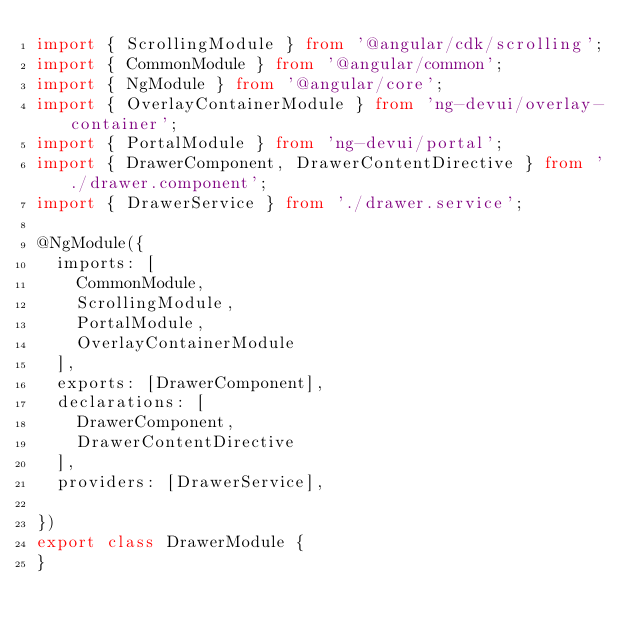<code> <loc_0><loc_0><loc_500><loc_500><_TypeScript_>import { ScrollingModule } from '@angular/cdk/scrolling';
import { CommonModule } from '@angular/common';
import { NgModule } from '@angular/core';
import { OverlayContainerModule } from 'ng-devui/overlay-container';
import { PortalModule } from 'ng-devui/portal';
import { DrawerComponent, DrawerContentDirective } from './drawer.component';
import { DrawerService } from './drawer.service';

@NgModule({
  imports: [
    CommonModule,
    ScrollingModule,
    PortalModule,
    OverlayContainerModule
  ],
  exports: [DrawerComponent],
  declarations: [
    DrawerComponent,
    DrawerContentDirective
  ],
  providers: [DrawerService],

})
export class DrawerModule {
}
</code> 